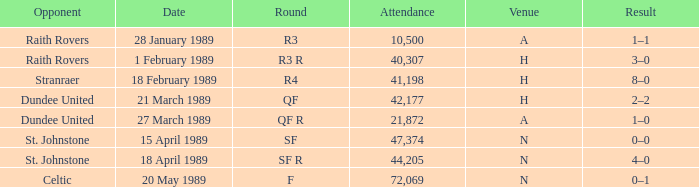What is the date when the round is sf? 15 April 1989. 